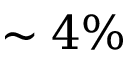Convert formula to latex. <formula><loc_0><loc_0><loc_500><loc_500>\sim 4 \%</formula> 